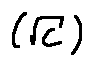<formula> <loc_0><loc_0><loc_500><loc_500>( \sqrt { C } )</formula> 